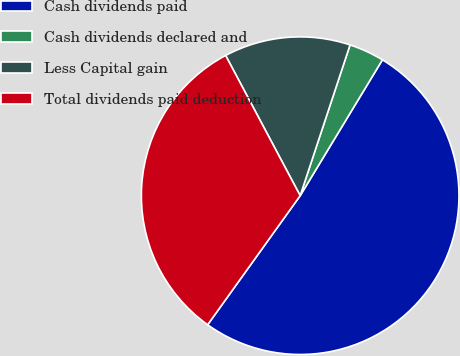<chart> <loc_0><loc_0><loc_500><loc_500><pie_chart><fcel>Cash dividends paid<fcel>Cash dividends declared and<fcel>Less Capital gain<fcel>Total dividends paid deduction<nl><fcel>51.23%<fcel>3.58%<fcel>12.86%<fcel>32.32%<nl></chart> 